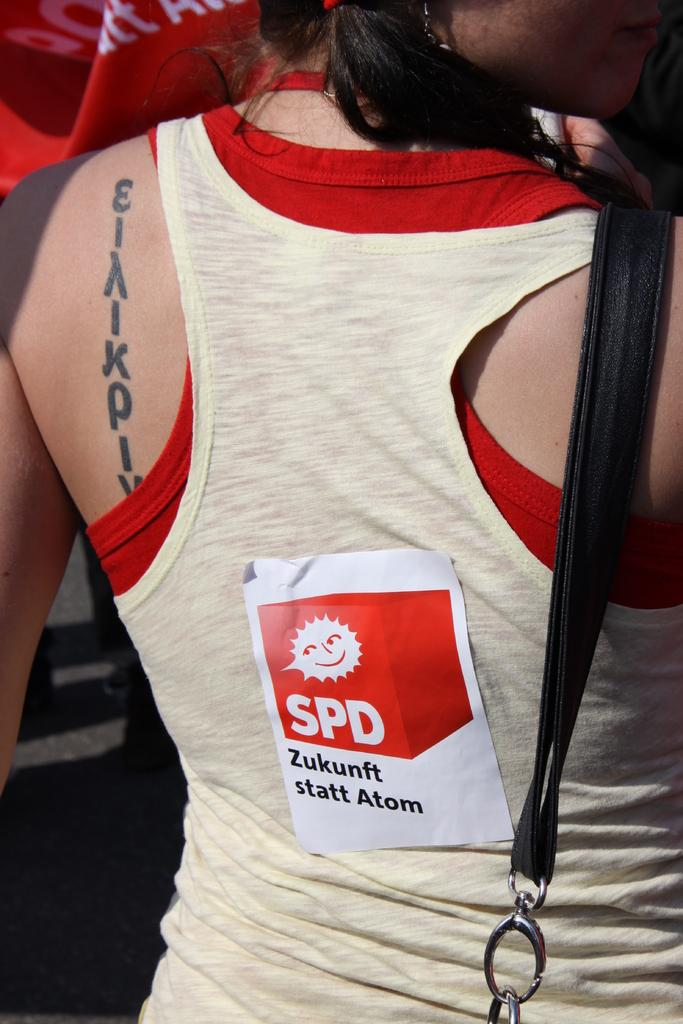<image>
Provide a brief description of the given image. a person has a sticker on their back with Zukunft statt Atom on it 